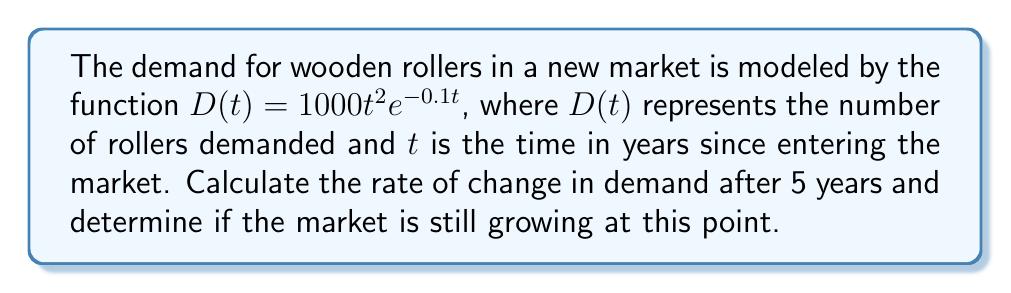Solve this math problem. To solve this problem, we need to follow these steps:

1) First, we need to find the derivative of the demand function $D(t)$. Using the product rule and chain rule:

   $$\frac{d}{dt}[D(t)] = \frac{d}{dt}[1000t^2e^{-0.1t}]$$
   $$= 1000 \cdot \frac{d}{dt}[t^2] \cdot e^{-0.1t} + 1000t^2 \cdot \frac{d}{dt}[e^{-0.1t}]$$
   $$= 1000 \cdot 2t \cdot e^{-0.1t} + 1000t^2 \cdot (-0.1e^{-0.1t})$$
   $$= 2000te^{-0.1t} - 100t^2e^{-0.1t}$$
   $$= (2000t - 100t^2)e^{-0.1t}$$

2) Now, we need to evaluate this derivative at $t = 5$:

   $$D'(5) = (2000 \cdot 5 - 100 \cdot 5^2)e^{-0.1 \cdot 5}$$
   $$= (10000 - 2500)e^{-0.5}$$
   $$= 7500e^{-0.5}$$
   $$\approx 4549.36$$

3) To determine if the market is still growing at this point, we need to check if $D'(5)$ is positive:

   Since $7500e^{-0.5} \approx 4549.36 > 0$, the market is still growing after 5 years.
Answer: $D'(5) \approx 4549.36$; market is still growing 